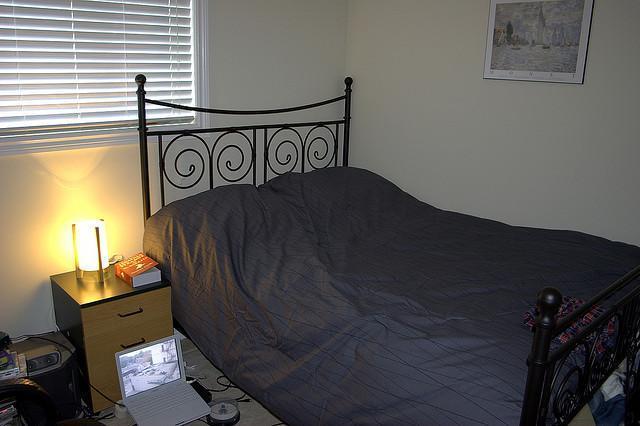How many cakes are on the table?
Give a very brief answer. 0. 